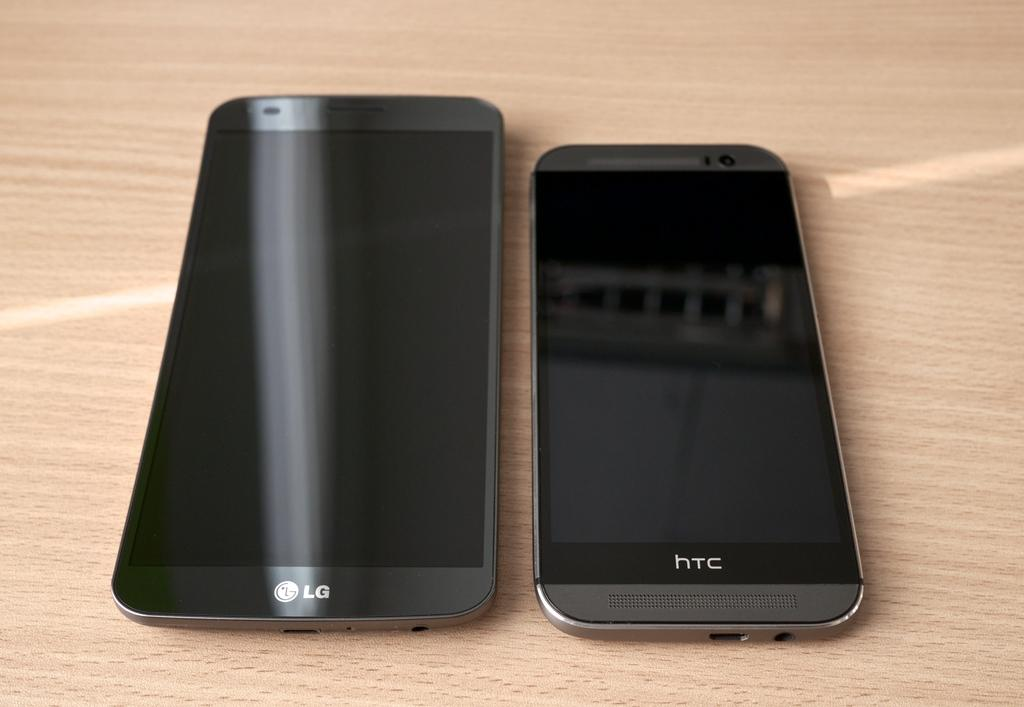<image>
Render a clear and concise summary of the photo. An LG phone lies on a table next to a HTC phone. 